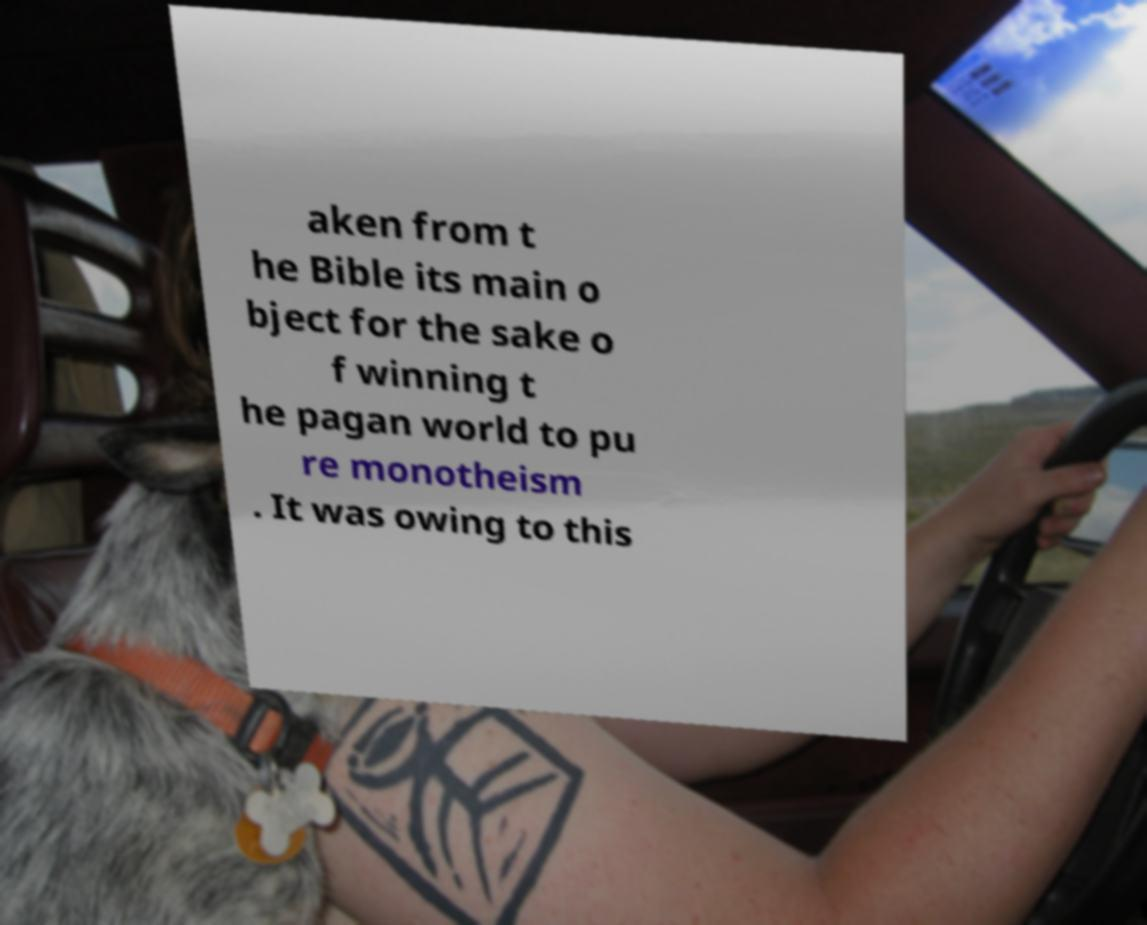There's text embedded in this image that I need extracted. Can you transcribe it verbatim? aken from t he Bible its main o bject for the sake o f winning t he pagan world to pu re monotheism . It was owing to this 